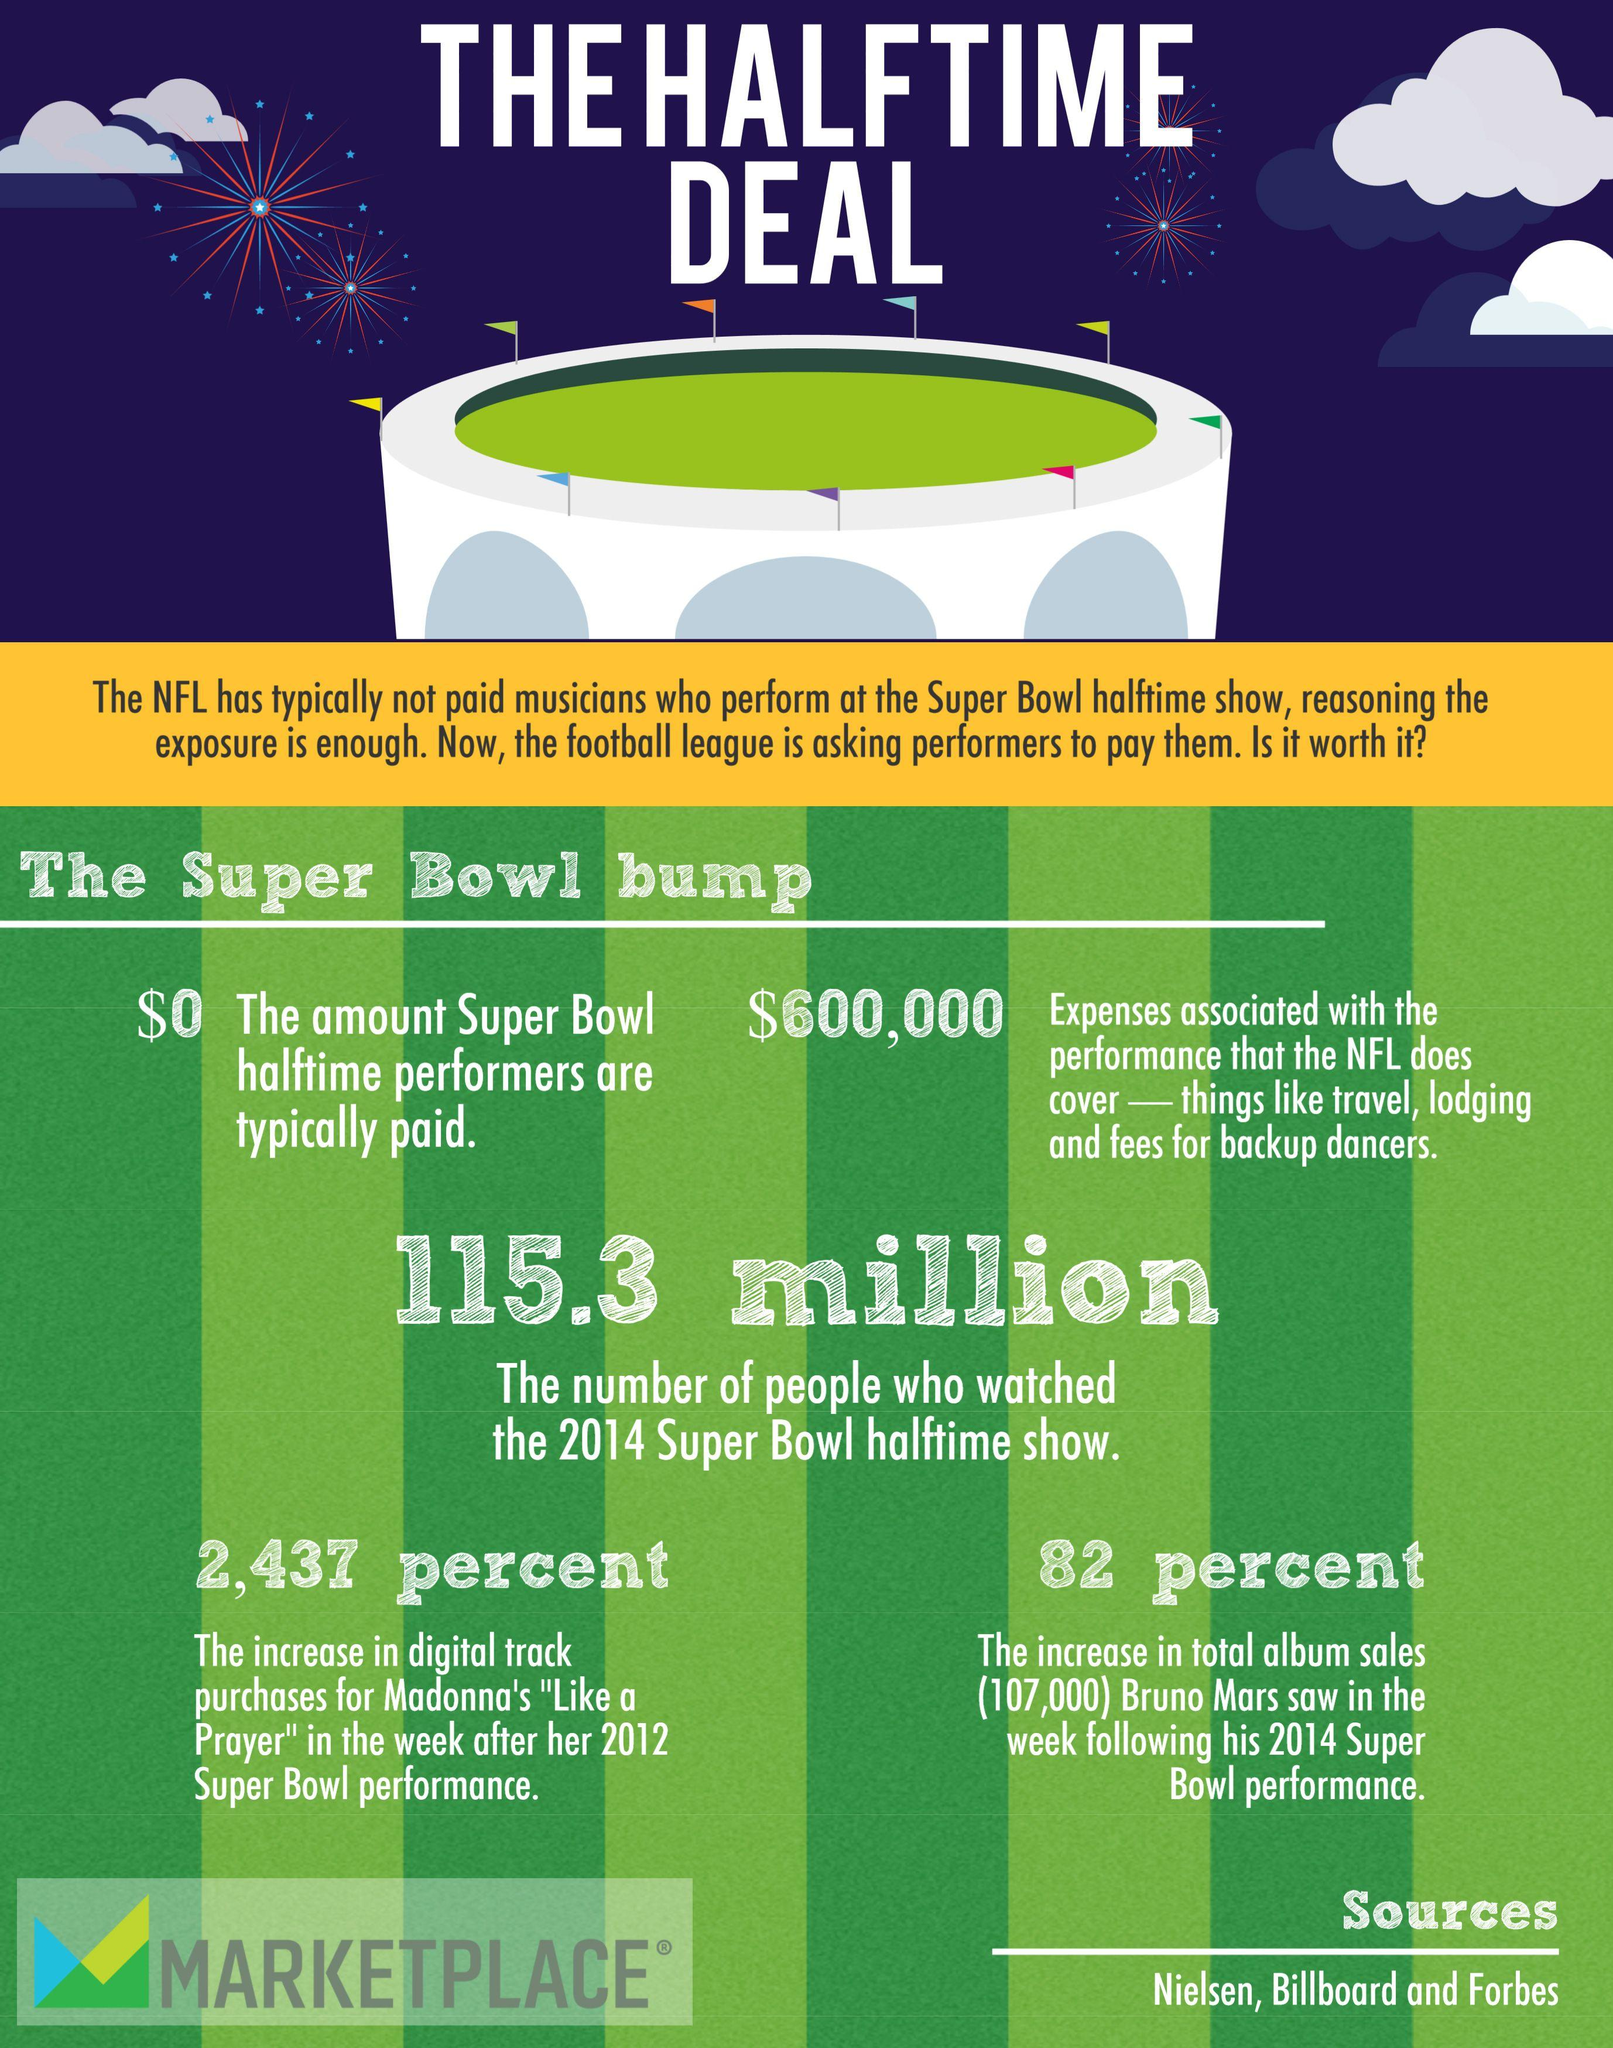Point out several critical features in this image. In 2014, the Super Bowl halftime show attracted a record-breaking 115.3 million viewers. Following his 2014 Super Bowl performance, Bruno Mars' total album sales experienced a percent increase of 82%. I, [name], declare that the amount paid to Super Bowl half time performers is $0. 